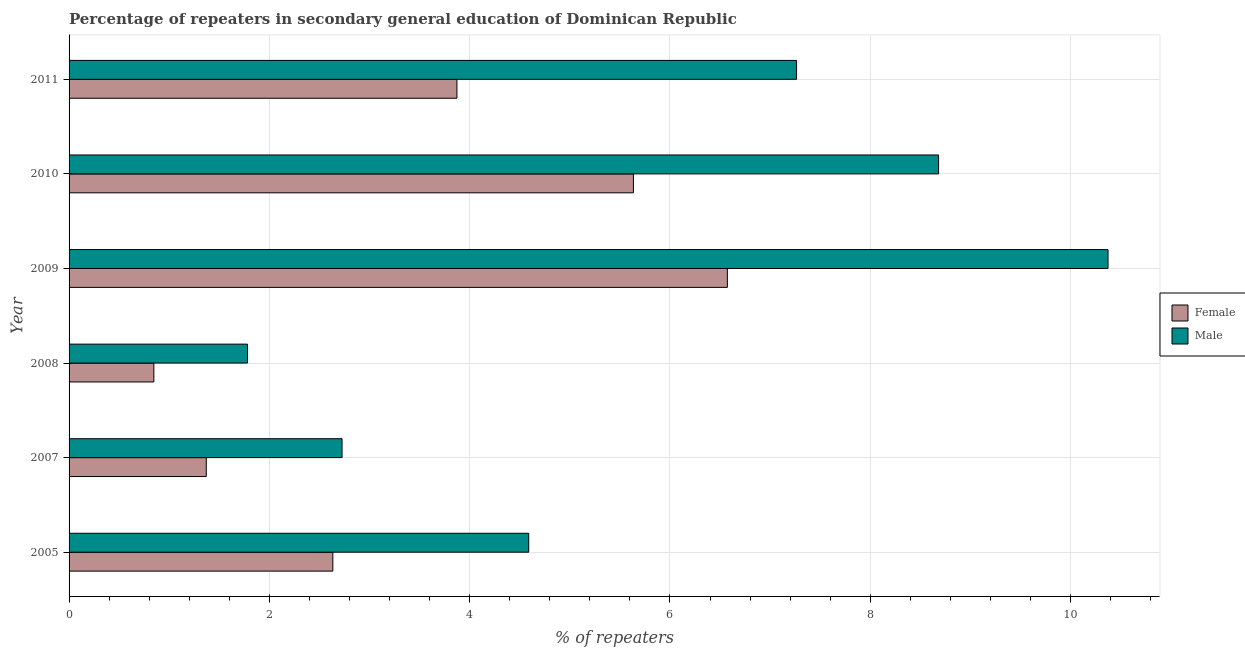How many groups of bars are there?
Give a very brief answer. 6. Are the number of bars on each tick of the Y-axis equal?
Provide a succinct answer. Yes. How many bars are there on the 3rd tick from the top?
Your response must be concise. 2. How many bars are there on the 4th tick from the bottom?
Your response must be concise. 2. What is the label of the 5th group of bars from the top?
Your answer should be very brief. 2007. In how many cases, is the number of bars for a given year not equal to the number of legend labels?
Your answer should be very brief. 0. What is the percentage of male repeaters in 2008?
Your response must be concise. 1.78. Across all years, what is the maximum percentage of male repeaters?
Ensure brevity in your answer.  10.37. Across all years, what is the minimum percentage of male repeaters?
Offer a terse response. 1.78. What is the total percentage of male repeaters in the graph?
Your response must be concise. 35.42. What is the difference between the percentage of male repeaters in 2008 and that in 2009?
Offer a very short reply. -8.59. What is the difference between the percentage of female repeaters in 2009 and the percentage of male repeaters in 2011?
Offer a very short reply. -0.69. What is the average percentage of male repeaters per year?
Keep it short and to the point. 5.9. In the year 2007, what is the difference between the percentage of female repeaters and percentage of male repeaters?
Keep it short and to the point. -1.36. What is the ratio of the percentage of female repeaters in 2007 to that in 2011?
Make the answer very short. 0.35. Is the percentage of male repeaters in 2005 less than that in 2008?
Offer a terse response. No. What is the difference between the highest and the second highest percentage of male repeaters?
Provide a succinct answer. 1.69. What is the difference between the highest and the lowest percentage of male repeaters?
Keep it short and to the point. 8.59. In how many years, is the percentage of female repeaters greater than the average percentage of female repeaters taken over all years?
Ensure brevity in your answer.  3. Is the sum of the percentage of male repeaters in 2009 and 2011 greater than the maximum percentage of female repeaters across all years?
Keep it short and to the point. Yes. What does the 2nd bar from the bottom in 2010 represents?
Keep it short and to the point. Male. How many bars are there?
Your response must be concise. 12. Are all the bars in the graph horizontal?
Your answer should be very brief. Yes. How many years are there in the graph?
Make the answer very short. 6. What is the difference between two consecutive major ticks on the X-axis?
Offer a very short reply. 2. Are the values on the major ticks of X-axis written in scientific E-notation?
Give a very brief answer. No. Does the graph contain any zero values?
Provide a short and direct response. No. Does the graph contain grids?
Offer a terse response. Yes. How many legend labels are there?
Ensure brevity in your answer.  2. How are the legend labels stacked?
Provide a short and direct response. Vertical. What is the title of the graph?
Provide a short and direct response. Percentage of repeaters in secondary general education of Dominican Republic. What is the label or title of the X-axis?
Offer a terse response. % of repeaters. What is the % of repeaters in Female in 2005?
Keep it short and to the point. 2.63. What is the % of repeaters in Male in 2005?
Provide a succinct answer. 4.59. What is the % of repeaters in Female in 2007?
Provide a short and direct response. 1.37. What is the % of repeaters of Male in 2007?
Offer a terse response. 2.73. What is the % of repeaters of Female in 2008?
Provide a succinct answer. 0.85. What is the % of repeaters in Male in 2008?
Your answer should be very brief. 1.78. What is the % of repeaters of Female in 2009?
Keep it short and to the point. 6.57. What is the % of repeaters of Male in 2009?
Provide a succinct answer. 10.37. What is the % of repeaters of Female in 2010?
Make the answer very short. 5.64. What is the % of repeaters in Male in 2010?
Provide a short and direct response. 8.68. What is the % of repeaters in Female in 2011?
Offer a very short reply. 3.87. What is the % of repeaters of Male in 2011?
Offer a terse response. 7.26. Across all years, what is the maximum % of repeaters in Female?
Your answer should be very brief. 6.57. Across all years, what is the maximum % of repeaters of Male?
Provide a short and direct response. 10.37. Across all years, what is the minimum % of repeaters in Female?
Offer a very short reply. 0.85. Across all years, what is the minimum % of repeaters of Male?
Offer a very short reply. 1.78. What is the total % of repeaters in Female in the graph?
Provide a short and direct response. 20.93. What is the total % of repeaters of Male in the graph?
Give a very brief answer. 35.42. What is the difference between the % of repeaters in Female in 2005 and that in 2007?
Provide a succinct answer. 1.26. What is the difference between the % of repeaters of Male in 2005 and that in 2007?
Offer a terse response. 1.86. What is the difference between the % of repeaters in Female in 2005 and that in 2008?
Provide a succinct answer. 1.79. What is the difference between the % of repeaters of Male in 2005 and that in 2008?
Your answer should be compact. 2.81. What is the difference between the % of repeaters of Female in 2005 and that in 2009?
Offer a very short reply. -3.94. What is the difference between the % of repeaters in Male in 2005 and that in 2009?
Provide a short and direct response. -5.78. What is the difference between the % of repeaters in Female in 2005 and that in 2010?
Your answer should be very brief. -3. What is the difference between the % of repeaters in Male in 2005 and that in 2010?
Your answer should be compact. -4.09. What is the difference between the % of repeaters of Female in 2005 and that in 2011?
Your response must be concise. -1.24. What is the difference between the % of repeaters of Male in 2005 and that in 2011?
Offer a terse response. -2.67. What is the difference between the % of repeaters of Female in 2007 and that in 2008?
Keep it short and to the point. 0.52. What is the difference between the % of repeaters in Male in 2007 and that in 2008?
Your answer should be very brief. 0.94. What is the difference between the % of repeaters in Female in 2007 and that in 2009?
Make the answer very short. -5.2. What is the difference between the % of repeaters of Male in 2007 and that in 2009?
Provide a succinct answer. -7.65. What is the difference between the % of repeaters of Female in 2007 and that in 2010?
Give a very brief answer. -4.27. What is the difference between the % of repeaters in Male in 2007 and that in 2010?
Offer a terse response. -5.96. What is the difference between the % of repeaters in Female in 2007 and that in 2011?
Your answer should be very brief. -2.5. What is the difference between the % of repeaters of Male in 2007 and that in 2011?
Provide a succinct answer. -4.54. What is the difference between the % of repeaters in Female in 2008 and that in 2009?
Ensure brevity in your answer.  -5.73. What is the difference between the % of repeaters of Male in 2008 and that in 2009?
Make the answer very short. -8.59. What is the difference between the % of repeaters in Female in 2008 and that in 2010?
Your response must be concise. -4.79. What is the difference between the % of repeaters in Male in 2008 and that in 2010?
Offer a very short reply. -6.9. What is the difference between the % of repeaters of Female in 2008 and that in 2011?
Your answer should be very brief. -3.03. What is the difference between the % of repeaters in Male in 2008 and that in 2011?
Ensure brevity in your answer.  -5.48. What is the difference between the % of repeaters in Female in 2009 and that in 2010?
Your answer should be very brief. 0.94. What is the difference between the % of repeaters of Male in 2009 and that in 2010?
Provide a succinct answer. 1.69. What is the difference between the % of repeaters in Female in 2009 and that in 2011?
Offer a very short reply. 2.7. What is the difference between the % of repeaters of Male in 2009 and that in 2011?
Keep it short and to the point. 3.11. What is the difference between the % of repeaters in Female in 2010 and that in 2011?
Give a very brief answer. 1.76. What is the difference between the % of repeaters in Male in 2010 and that in 2011?
Give a very brief answer. 1.42. What is the difference between the % of repeaters of Female in 2005 and the % of repeaters of Male in 2007?
Offer a terse response. -0.09. What is the difference between the % of repeaters in Female in 2005 and the % of repeaters in Male in 2008?
Your answer should be very brief. 0.85. What is the difference between the % of repeaters of Female in 2005 and the % of repeaters of Male in 2009?
Provide a short and direct response. -7.74. What is the difference between the % of repeaters in Female in 2005 and the % of repeaters in Male in 2010?
Give a very brief answer. -6.05. What is the difference between the % of repeaters in Female in 2005 and the % of repeaters in Male in 2011?
Make the answer very short. -4.63. What is the difference between the % of repeaters in Female in 2007 and the % of repeaters in Male in 2008?
Offer a terse response. -0.41. What is the difference between the % of repeaters of Female in 2007 and the % of repeaters of Male in 2009?
Ensure brevity in your answer.  -9. What is the difference between the % of repeaters of Female in 2007 and the % of repeaters of Male in 2010?
Ensure brevity in your answer.  -7.31. What is the difference between the % of repeaters of Female in 2007 and the % of repeaters of Male in 2011?
Make the answer very short. -5.89. What is the difference between the % of repeaters in Female in 2008 and the % of repeaters in Male in 2009?
Ensure brevity in your answer.  -9.53. What is the difference between the % of repeaters in Female in 2008 and the % of repeaters in Male in 2010?
Offer a very short reply. -7.84. What is the difference between the % of repeaters of Female in 2008 and the % of repeaters of Male in 2011?
Ensure brevity in your answer.  -6.42. What is the difference between the % of repeaters in Female in 2009 and the % of repeaters in Male in 2010?
Make the answer very short. -2.11. What is the difference between the % of repeaters in Female in 2009 and the % of repeaters in Male in 2011?
Your response must be concise. -0.69. What is the difference between the % of repeaters of Female in 2010 and the % of repeaters of Male in 2011?
Keep it short and to the point. -1.63. What is the average % of repeaters in Female per year?
Provide a short and direct response. 3.49. What is the average % of repeaters of Male per year?
Keep it short and to the point. 5.9. In the year 2005, what is the difference between the % of repeaters of Female and % of repeaters of Male?
Your response must be concise. -1.96. In the year 2007, what is the difference between the % of repeaters in Female and % of repeaters in Male?
Your response must be concise. -1.36. In the year 2008, what is the difference between the % of repeaters of Female and % of repeaters of Male?
Give a very brief answer. -0.94. In the year 2009, what is the difference between the % of repeaters in Female and % of repeaters in Male?
Provide a short and direct response. -3.8. In the year 2010, what is the difference between the % of repeaters in Female and % of repeaters in Male?
Offer a very short reply. -3.05. In the year 2011, what is the difference between the % of repeaters of Female and % of repeaters of Male?
Your answer should be compact. -3.39. What is the ratio of the % of repeaters of Female in 2005 to that in 2007?
Your answer should be very brief. 1.92. What is the ratio of the % of repeaters in Male in 2005 to that in 2007?
Give a very brief answer. 1.68. What is the ratio of the % of repeaters of Female in 2005 to that in 2008?
Offer a very short reply. 3.11. What is the ratio of the % of repeaters of Male in 2005 to that in 2008?
Offer a very short reply. 2.58. What is the ratio of the % of repeaters in Female in 2005 to that in 2009?
Keep it short and to the point. 0.4. What is the ratio of the % of repeaters of Male in 2005 to that in 2009?
Give a very brief answer. 0.44. What is the ratio of the % of repeaters in Female in 2005 to that in 2010?
Your answer should be very brief. 0.47. What is the ratio of the % of repeaters in Male in 2005 to that in 2010?
Your response must be concise. 0.53. What is the ratio of the % of repeaters in Female in 2005 to that in 2011?
Your answer should be very brief. 0.68. What is the ratio of the % of repeaters in Male in 2005 to that in 2011?
Your answer should be compact. 0.63. What is the ratio of the % of repeaters in Female in 2007 to that in 2008?
Your answer should be very brief. 1.62. What is the ratio of the % of repeaters in Male in 2007 to that in 2008?
Provide a short and direct response. 1.53. What is the ratio of the % of repeaters in Female in 2007 to that in 2009?
Provide a short and direct response. 0.21. What is the ratio of the % of repeaters of Male in 2007 to that in 2009?
Provide a succinct answer. 0.26. What is the ratio of the % of repeaters in Female in 2007 to that in 2010?
Offer a terse response. 0.24. What is the ratio of the % of repeaters of Male in 2007 to that in 2010?
Keep it short and to the point. 0.31. What is the ratio of the % of repeaters in Female in 2007 to that in 2011?
Your response must be concise. 0.35. What is the ratio of the % of repeaters in Male in 2007 to that in 2011?
Give a very brief answer. 0.38. What is the ratio of the % of repeaters in Female in 2008 to that in 2009?
Ensure brevity in your answer.  0.13. What is the ratio of the % of repeaters of Male in 2008 to that in 2009?
Offer a very short reply. 0.17. What is the ratio of the % of repeaters in Female in 2008 to that in 2010?
Your response must be concise. 0.15. What is the ratio of the % of repeaters of Male in 2008 to that in 2010?
Give a very brief answer. 0.21. What is the ratio of the % of repeaters in Female in 2008 to that in 2011?
Offer a very short reply. 0.22. What is the ratio of the % of repeaters in Male in 2008 to that in 2011?
Ensure brevity in your answer.  0.25. What is the ratio of the % of repeaters in Female in 2009 to that in 2010?
Ensure brevity in your answer.  1.17. What is the ratio of the % of repeaters of Male in 2009 to that in 2010?
Make the answer very short. 1.19. What is the ratio of the % of repeaters in Female in 2009 to that in 2011?
Your answer should be compact. 1.7. What is the ratio of the % of repeaters in Male in 2009 to that in 2011?
Offer a terse response. 1.43. What is the ratio of the % of repeaters of Female in 2010 to that in 2011?
Offer a terse response. 1.46. What is the ratio of the % of repeaters in Male in 2010 to that in 2011?
Give a very brief answer. 1.2. What is the difference between the highest and the second highest % of repeaters of Female?
Keep it short and to the point. 0.94. What is the difference between the highest and the second highest % of repeaters in Male?
Keep it short and to the point. 1.69. What is the difference between the highest and the lowest % of repeaters of Female?
Your answer should be very brief. 5.73. What is the difference between the highest and the lowest % of repeaters of Male?
Give a very brief answer. 8.59. 